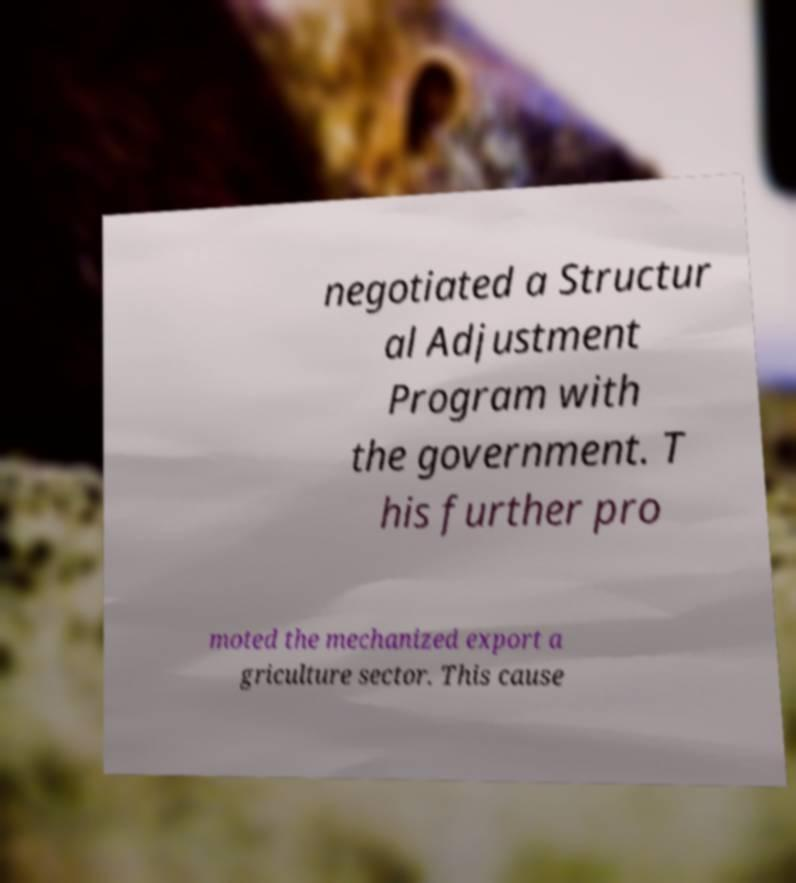Could you extract and type out the text from this image? negotiated a Structur al Adjustment Program with the government. T his further pro moted the mechanized export a griculture sector. This cause 